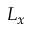<formula> <loc_0><loc_0><loc_500><loc_500>L _ { x }</formula> 